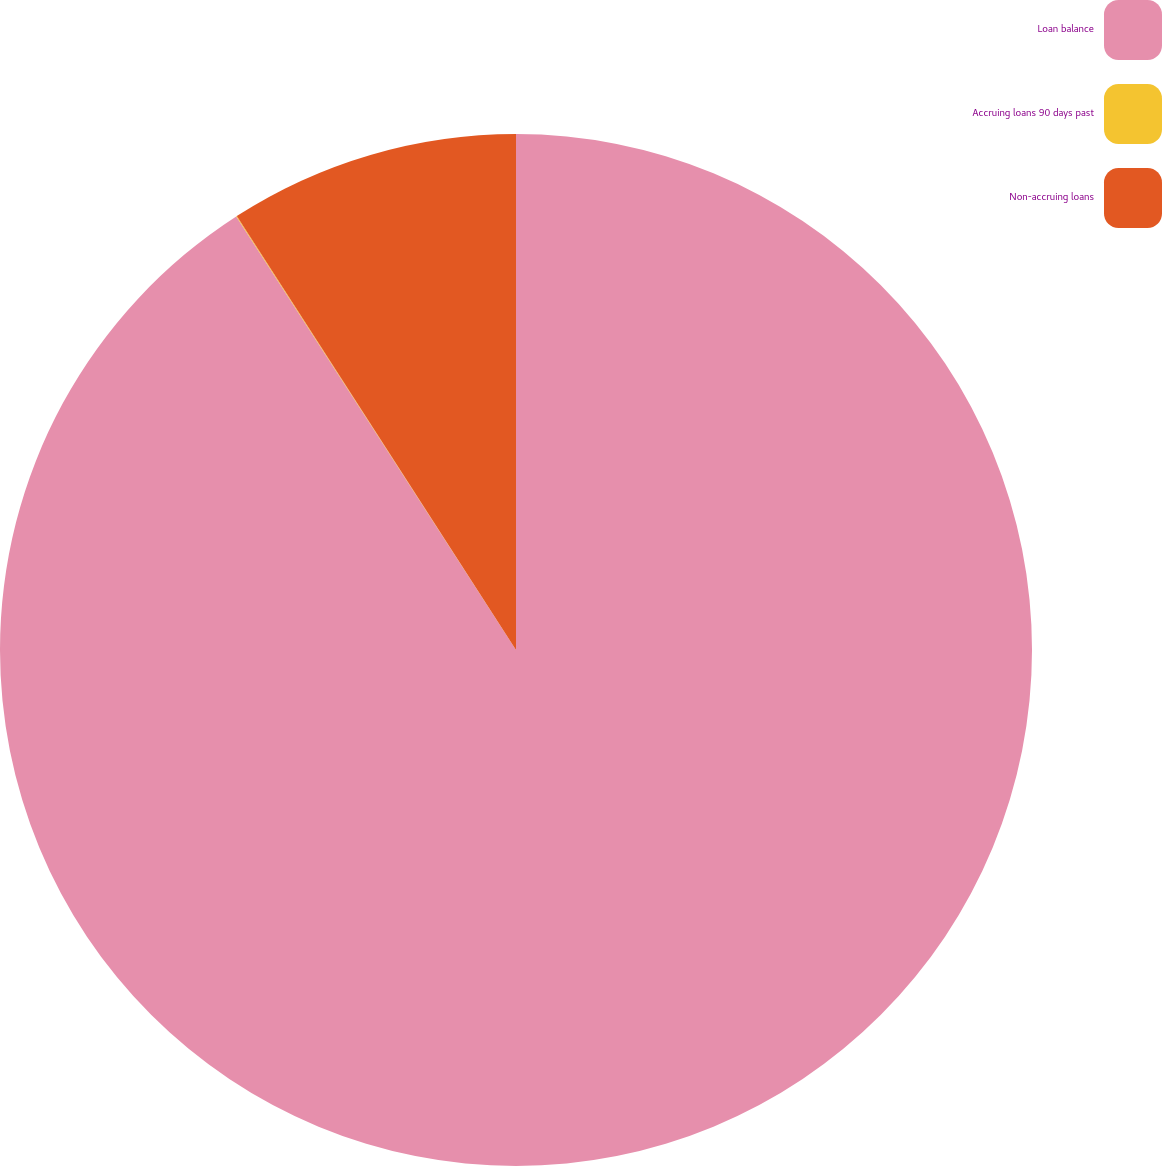Convert chart to OTSL. <chart><loc_0><loc_0><loc_500><loc_500><pie_chart><fcel>Loan balance<fcel>Accruing loans 90 days past<fcel>Non-accruing loans<nl><fcel>90.88%<fcel>0.02%<fcel>9.1%<nl></chart> 